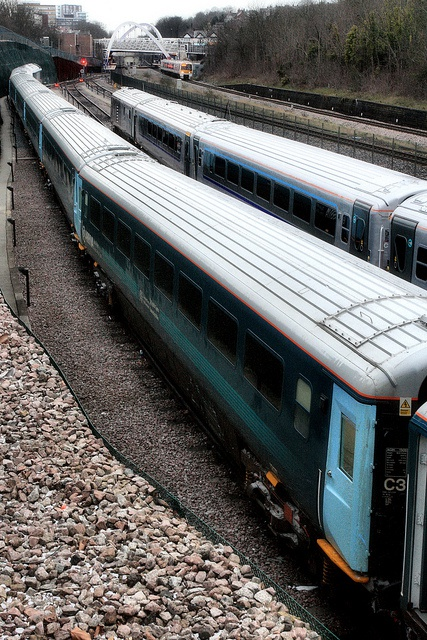Describe the objects in this image and their specific colors. I can see train in darkgray, black, white, and gray tones, train in darkgray, white, black, and gray tones, and train in darkgray, gray, black, and lightgray tones in this image. 